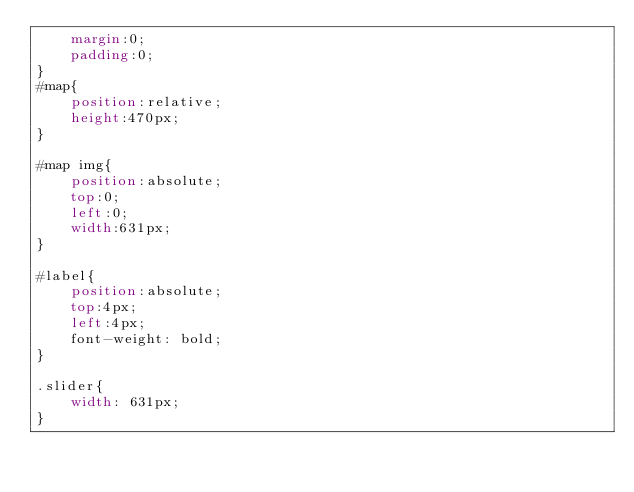Convert code to text. <code><loc_0><loc_0><loc_500><loc_500><_CSS_>	margin:0;
	padding:0;
}
#map{
	position:relative;
	height:470px;
}

#map img{
	position:absolute;
	top:0;
	left:0;
	width:631px;
}

#label{
	position:absolute;
	top:4px;
	left:4px;
	font-weight: bold;
}

.slider{
	width: 631px;
}</code> 